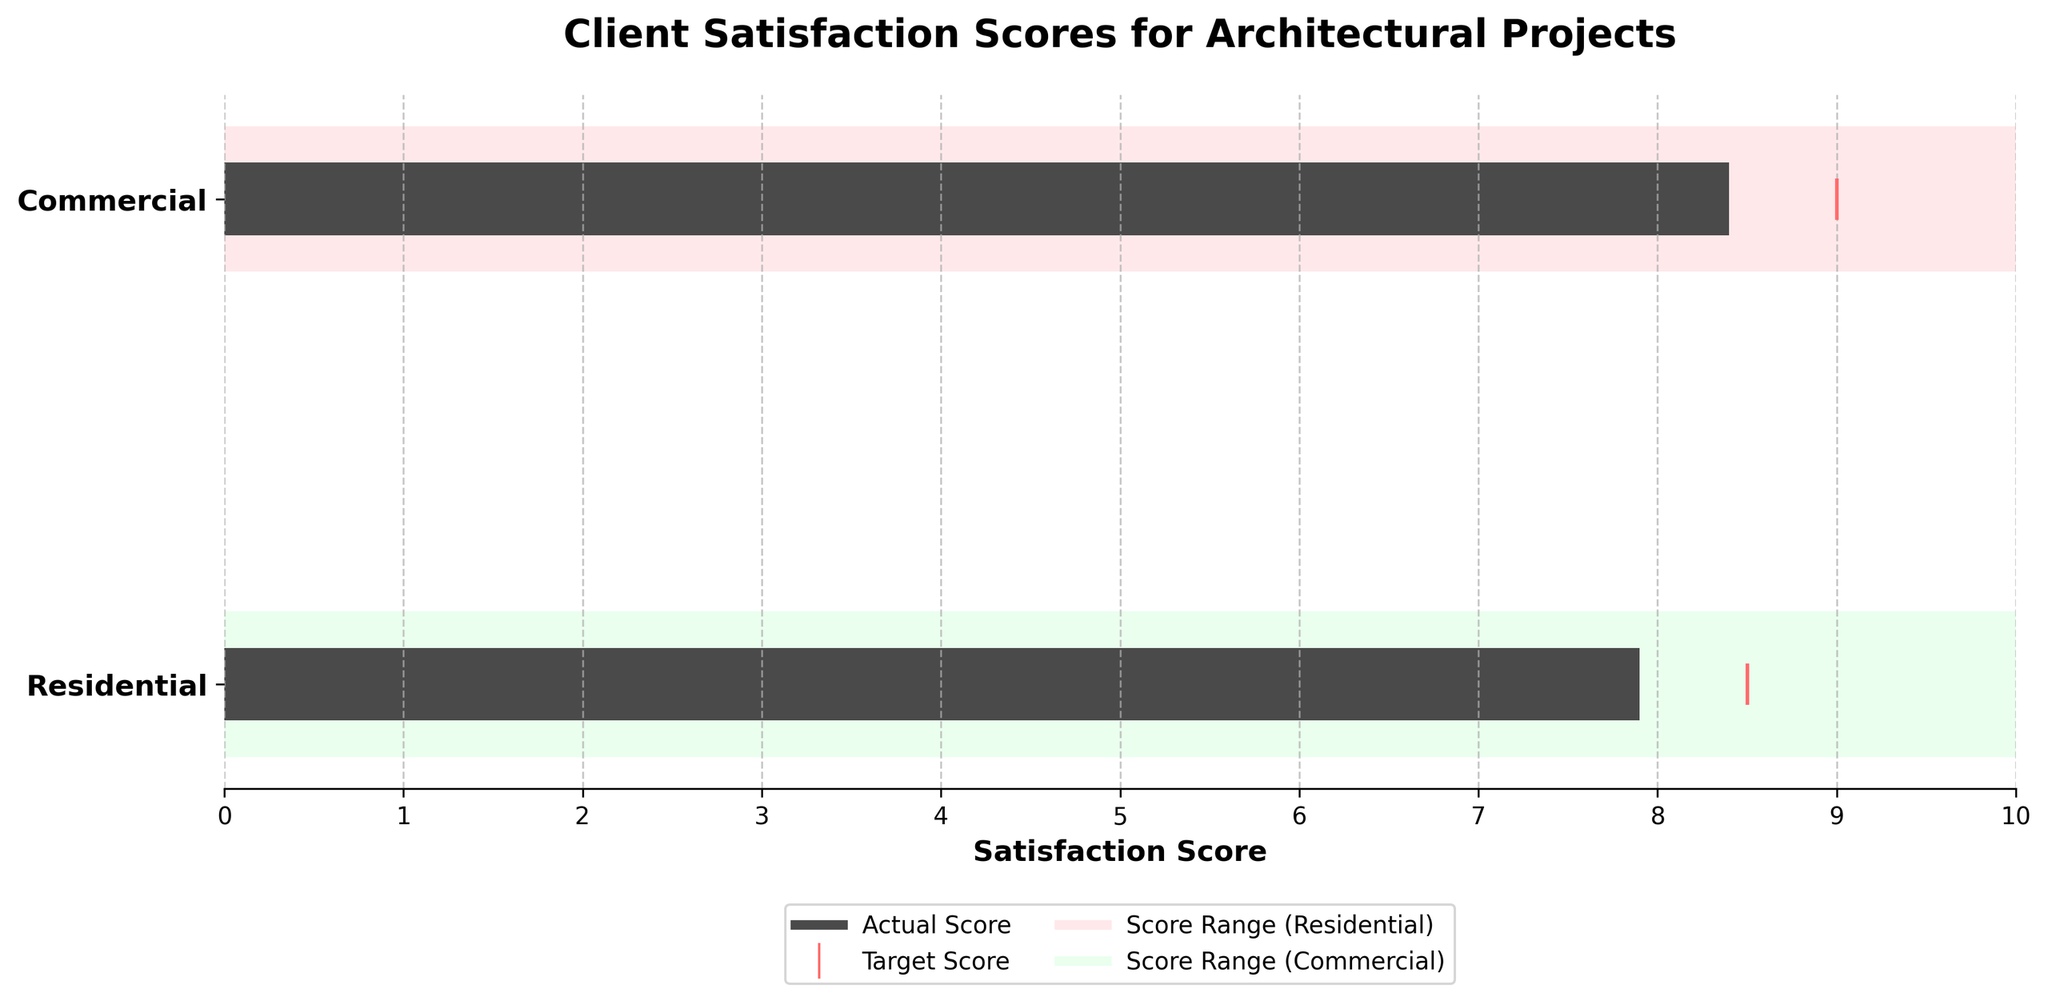What is the title of the chart? The title is given at the top of the chart and describes what the figure represents.
Answer: Client Satisfaction Scores for Architectural Projects Which project type has the higher target satisfaction score? The target scores are marked with a red vertical line, and comparing the positions for both project types, the commercial target score is at 8.5, while the residential target score is at 9.0.
Answer: Residential What is the actual satisfaction score for commercial projects? The actual scores are represented by solid dark bars within the ranges. For commercial projects, this dark bar stops at 7.9.
Answer: 7.9 In which satisfaction range does the Residential project score fall? The ranges are color-coded, with residential ranges starting at Poor (0-6), Average (6-7.5), and Excellent (7.5-10). The actual residential score is 8.4, which falls in the Excellent range.
Answer: Excellent How much does the actual score of residential projects differ from their target score? The target score for residential projects is 9.0, and the actual score is 8.4. The difference is 9.0 - 8.4 = 0.6.
Answer: 0.6 Are the actual scores of both project types closer to the Average or Excellent ranges? Both the actual scores for residential (8.4) and commercial (7.9) fall closer to the start of the Excellent range (7.5-10) than to their respective Average ranges (6-7.5).
Answer: Excellent Which project type has the wider Excellent range? For both project types, the Excellent range is from 7.5 to 10. Since both ranges span the same distance, neither has a wider Excellent range.
Answer: Neither How do the actual satisfaction scores for residential and commercial projects compare? Comparing the actual scores from the chart, the residential score is 8.4 while the commercial score is 7.9. Thus, the residential project has a higher actual satisfaction score.
Answer: Residential projects have a higher score In which range does the target score for commercial projects fall? The target score for commercial projects is marked at 8.5. Referring to the range markings, 8.5 falls within the Excellent range (7.5-10).
Answer: Excellent 